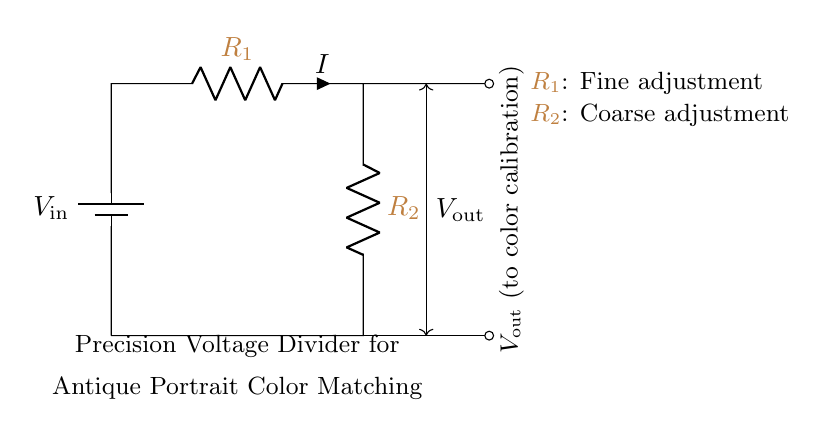What is the type of circuit shown? The circuit is a voltage divider, which is specifically designed to divide the input voltage into smaller output voltages based on the resistor values.
Answer: Voltage divider What components are in the circuit? The circuit contains two resistors, R1 and R2, and a battery providing the input voltage. The two resistors are connected in series, creating a voltage division.
Answer: R1, R2, battery What does Vout represent in this circuit? Vout represents the output voltage taken between the two resistors, which is supplied to the color calibration equipment. This voltage is a fraction of the input voltage based on the resistor values.
Answer: Output voltage What is the purpose of R1 and R2? R1 is for fine adjustment, allowing precise control over the output voltage, while R2 is for coarse adjustment, making it easier to set an approximate voltage level.
Answer: Fine adjustment and coarse adjustment What is the relationship between Vout and Vin? The relationship is defined by the voltage divider rule, expressed as Vout = Vin * (R2 / (R1 + R2)), indicating how the output voltage is a proportion of the input voltage.
Answer: Proportional What devices will use Vout from this circuit? Vout is meant for use by color calibration equipment that ensures accurate color reproduction in antique portrait illustrations.
Answer: Color calibration equipment What would happen if one resistor value is increased? Increasing one resistor value (e.g., R1 or R2) would change the ratio between R1 and R2, resulting in a different output voltage (Vout), as determined by the voltage divider formula.
Answer: Change in Vout 